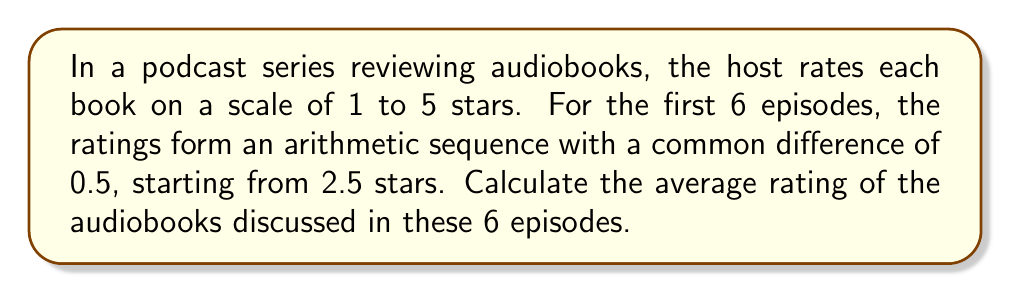Provide a solution to this math problem. Let's approach this step-by-step:

1) First, we need to identify the terms in the arithmetic sequence:
   $a_1 = 2.5$ (first term)
   $d = 0.5$ (common difference)
   $n = 6$ (number of terms)

2) The arithmetic sequence will be:
   2.5, 3.0, 3.5, 4.0, 4.5, 5.0

3) To find the average, we need to sum all terms and divide by the number of terms. We can use the formula for the sum of an arithmetic sequence:

   $$S_n = \frac{n}{2}(a_1 + a_n)$$

   Where $a_n$ is the last term, which we can calculate using:
   $$a_n = a_1 + (n-1)d$$

4) Let's calculate $a_n$:
   $$a_6 = 2.5 + (6-1)(0.5) = 2.5 + 2.5 = 5.0$$

5) Now we can calculate the sum:
   $$S_6 = \frac{6}{2}(2.5 + 5.0) = 3(7.5) = 22.5$$

6) To get the average, we divide the sum by the number of terms:
   $$\text{Average} = \frac{S_6}{6} = \frac{22.5}{6} = 3.75$$

Therefore, the average rating of the audiobooks is 3.75 stars.
Answer: 3.75 stars 